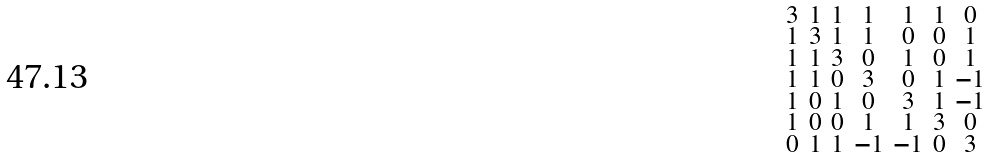Convert formula to latex. <formula><loc_0><loc_0><loc_500><loc_500>\begin{smallmatrix} 3 & 1 & 1 & 1 & 1 & 1 & 0 \\ 1 & 3 & 1 & 1 & 0 & 0 & 1 \\ 1 & 1 & 3 & 0 & 1 & 0 & 1 \\ 1 & 1 & 0 & 3 & 0 & 1 & - 1 \\ 1 & 0 & 1 & 0 & 3 & 1 & - 1 \\ 1 & 0 & 0 & 1 & 1 & 3 & 0 \\ 0 & 1 & 1 & - 1 & - 1 & 0 & 3 \end{smallmatrix}</formula> 